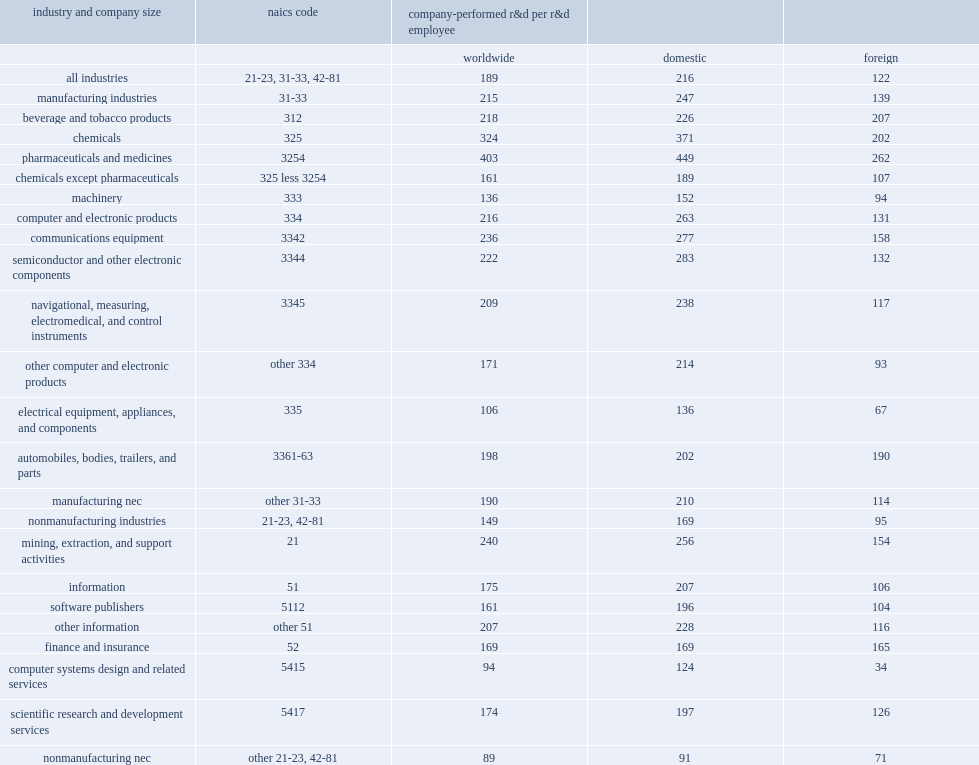On the basis of cost per r&d employee, how many percent did u.s. companies spend more on r&d performed domestically than on r&d performed outside the united states? 0.770492. On average, how many million dollars did u.s. companies spend on domestic r&d performance per u.s. r&d employee? 216.0. How many million dollars were spent on foreign r&d performance per foreign r&d employee? 122.0. 